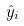<formula> <loc_0><loc_0><loc_500><loc_500>\hat { y } _ { i }</formula> 